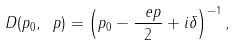Convert formula to latex. <formula><loc_0><loc_0><loc_500><loc_500>D ( p _ { 0 } , \ p ) = \left ( p _ { 0 } - \frac { \ e p } 2 + i \delta \right ) ^ { - 1 } ,</formula> 